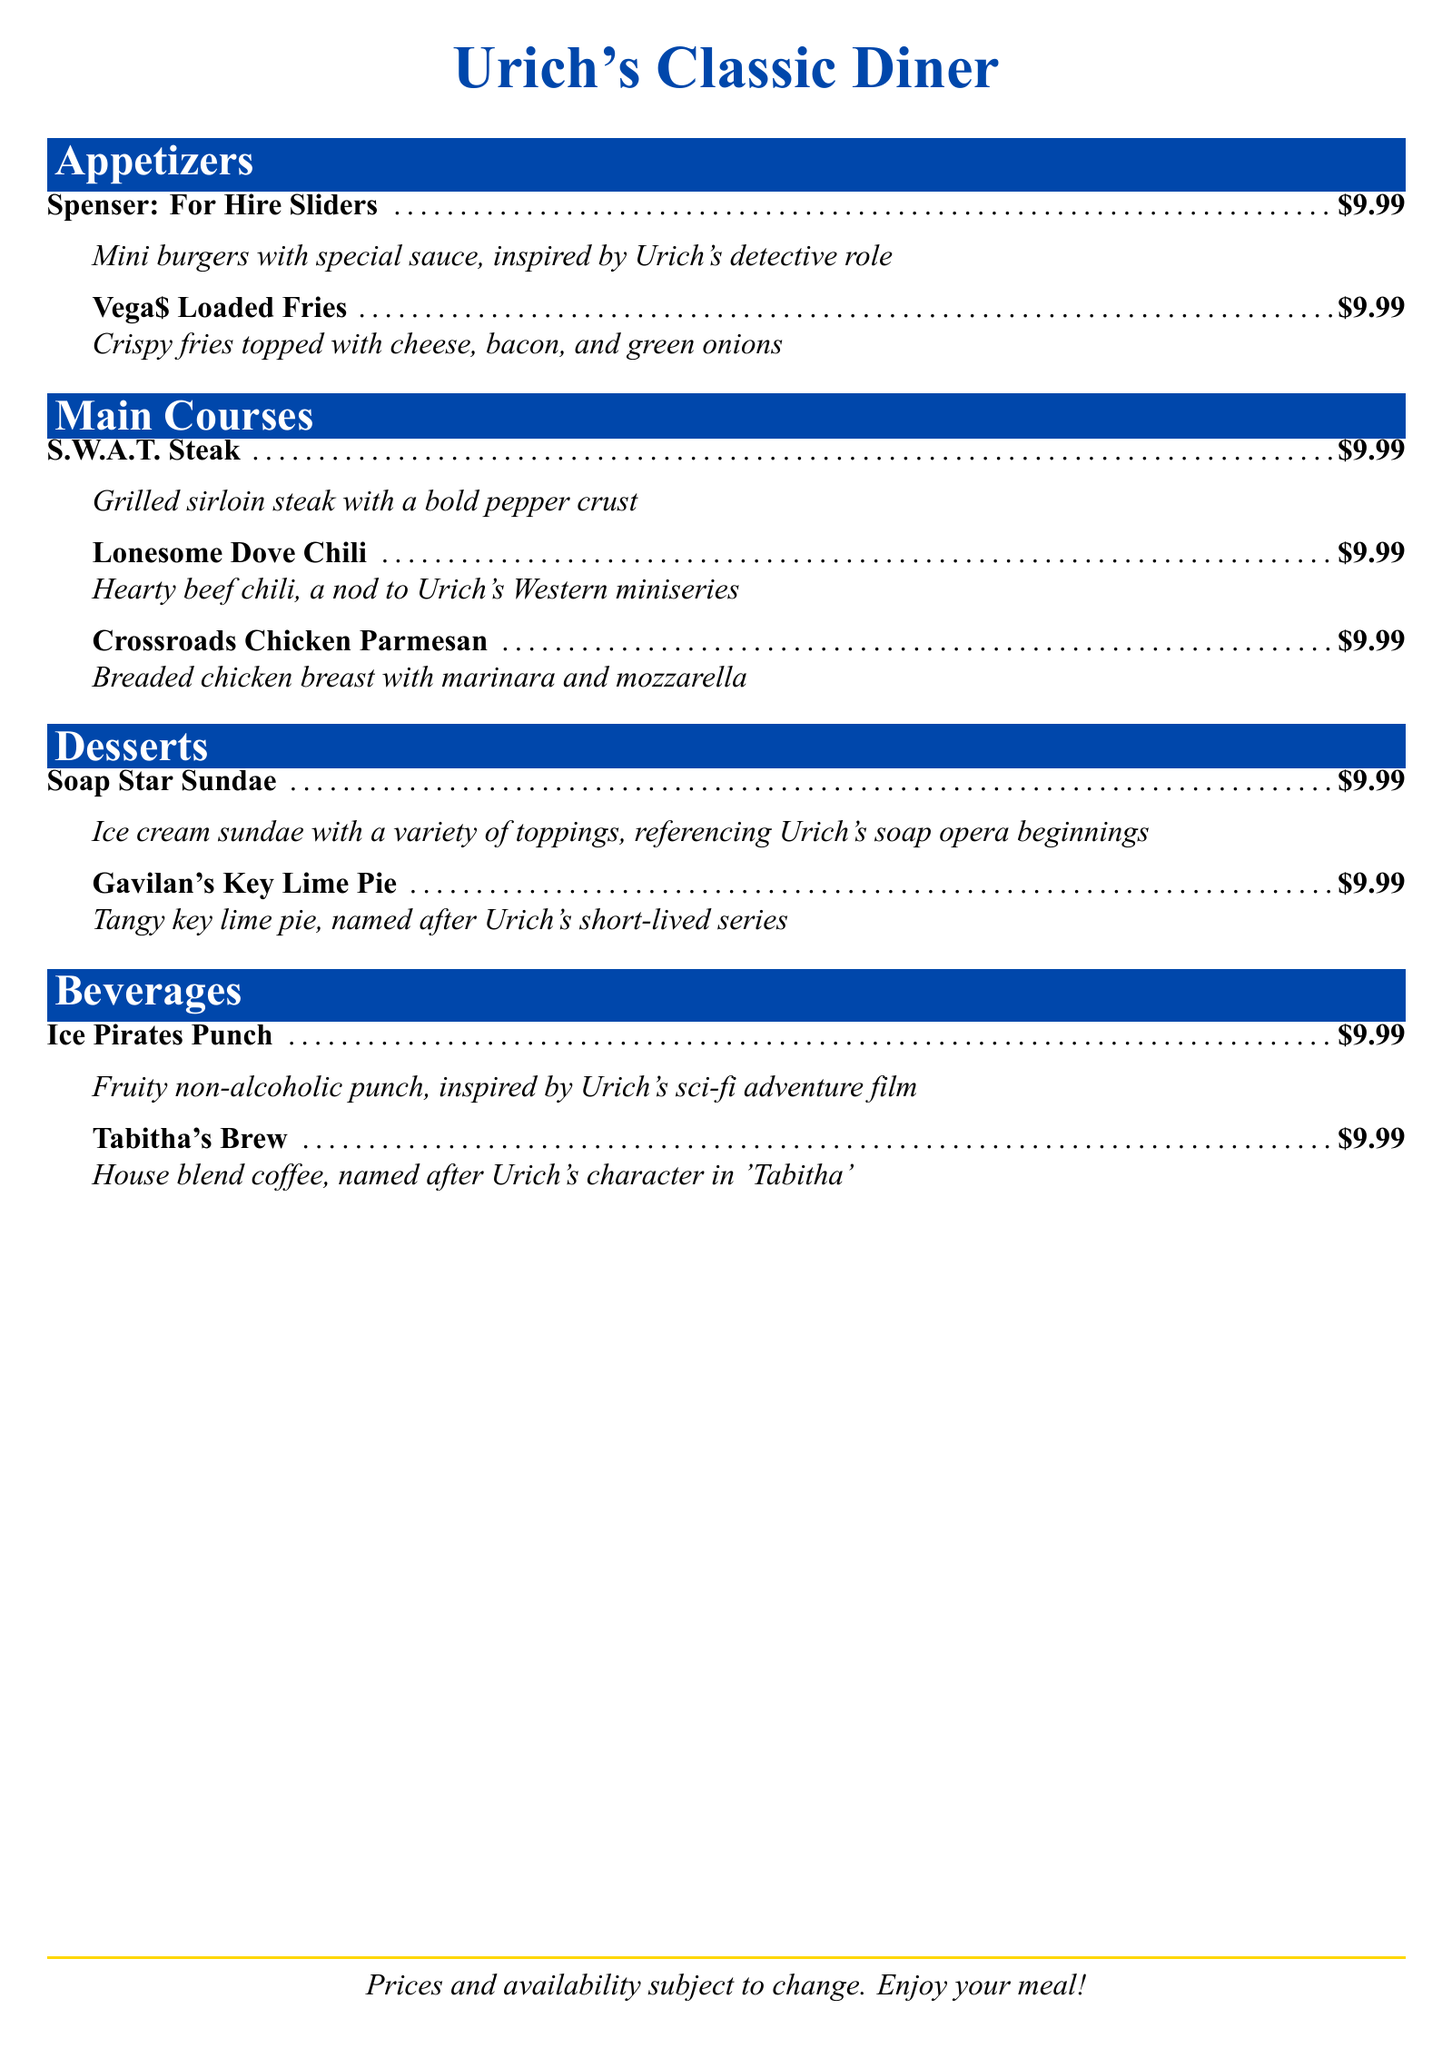What is the name of the diner? The name of the diner is presented at the top of the document as "Urich's Classic Diner."
Answer: Urich's Classic Diner What type of dish are the "Spenser: For Hire Sliders"? They are classified as appetizers, indicated under the "Appetizers" section.
Answer: Appetizers How much do all menu items cost? All menu items are uniformly priced at $9.99.
Answer: $9.99 Which dessert references Robert Urich's soap opera beginnings? The dessert correlated with Urich's soap opera beginnings is the "Soap Star Sundae."
Answer: Soap Star Sundae What is the main ingredient in the "Lonesome Dove Chili"? The key ingredient in this dish is beef, as noted in its description.
Answer: Beef Which beverage is inspired by a sci-fi adventure film? The beverage linked to a sci-fi adventure film is "Ice Pirates Punch."
Answer: Ice Pirates Punch How many appetizer items are on the menu? The number of appetizers provided is two, as listed in the "Appetizers" section.
Answer: Two What is the name of the dessert inspired by a short-lived series? The dessert associated with a short-lived series is "Gavilan's Key Lime Pie."
Answer: Gavilan's Key Lime Pie What main course does the menu suggest is a nod to a Western miniseries? The main course that refers to a Western miniseries is "Lonesome Dove Chili."
Answer: Lonesome Dove Chili 